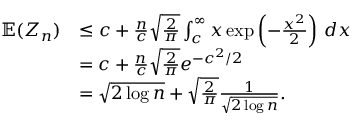<formula> <loc_0><loc_0><loc_500><loc_500>\begin{array} { r l } { \mathbb { E } ( Z _ { n } ) } & { \leq c + \frac { n } { c } \sqrt { \frac { 2 } { \pi } } \int _ { c } ^ { \infty } x \exp \left ( - \frac { x ^ { 2 } } { 2 } \right ) \, d x } \\ & { = c + \frac { n } { c } \sqrt { \frac { 2 } { \pi } } e ^ { - c ^ { 2 } / 2 } } \\ & { = \sqrt { 2 \log n } + \sqrt { \frac { 2 } { \pi } } \frac { 1 } { \sqrt { 2 \log n } } . } \end{array}</formula> 